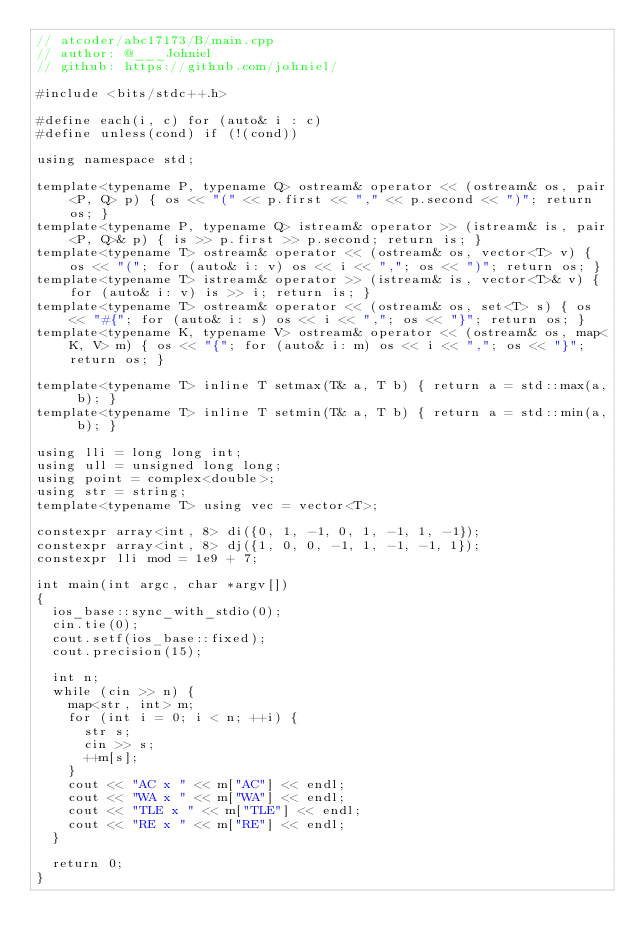Convert code to text. <code><loc_0><loc_0><loc_500><loc_500><_C++_>// atcoder/abc17173/B/main.cpp
// author: @___Johniel
// github: https://github.com/johniel/

#include <bits/stdc++.h>

#define each(i, c) for (auto& i : c)
#define unless(cond) if (!(cond))

using namespace std;

template<typename P, typename Q> ostream& operator << (ostream& os, pair<P, Q> p) { os << "(" << p.first << "," << p.second << ")"; return os; }
template<typename P, typename Q> istream& operator >> (istream& is, pair<P, Q>& p) { is >> p.first >> p.second; return is; }
template<typename T> ostream& operator << (ostream& os, vector<T> v) { os << "("; for (auto& i: v) os << i << ","; os << ")"; return os; }
template<typename T> istream& operator >> (istream& is, vector<T>& v) { for (auto& i: v) is >> i; return is; }
template<typename T> ostream& operator << (ostream& os, set<T> s) { os << "#{"; for (auto& i: s) os << i << ","; os << "}"; return os; }
template<typename K, typename V> ostream& operator << (ostream& os, map<K, V> m) { os << "{"; for (auto& i: m) os << i << ","; os << "}"; return os; }

template<typename T> inline T setmax(T& a, T b) { return a = std::max(a, b); }
template<typename T> inline T setmin(T& a, T b) { return a = std::min(a, b); }

using lli = long long int;
using ull = unsigned long long;
using point = complex<double>;
using str = string;
template<typename T> using vec = vector<T>;

constexpr array<int, 8> di({0, 1, -1, 0, 1, -1, 1, -1});
constexpr array<int, 8> dj({1, 0, 0, -1, 1, -1, -1, 1});
constexpr lli mod = 1e9 + 7;

int main(int argc, char *argv[])
{
  ios_base::sync_with_stdio(0);
  cin.tie(0);
  cout.setf(ios_base::fixed);
  cout.precision(15);

  int n;
  while (cin >> n) {
    map<str, int> m;
    for (int i = 0; i < n; ++i) {
      str s;
      cin >> s;
      ++m[s];
    }
    cout << "AC x " << m["AC"] << endl;
    cout << "WA x " << m["WA"] << endl;
    cout << "TLE x " << m["TLE"] << endl;
    cout << "RE x " << m["RE"] << endl;
  }

  return 0;
}
</code> 